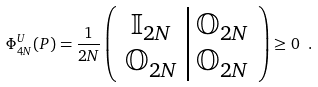<formula> <loc_0><loc_0><loc_500><loc_500>\Phi ^ { U } _ { 4 N } ( P ) = \frac { 1 } { 2 N } \left ( \begin{array} { c | c } \mathbb { I } _ { 2 N } & \mathbb { O } _ { 2 N } \\ \mathbb { O } _ { 2 N } & \mathbb { O } _ { 2 N } \end{array} \right ) \geq 0 \ .</formula> 